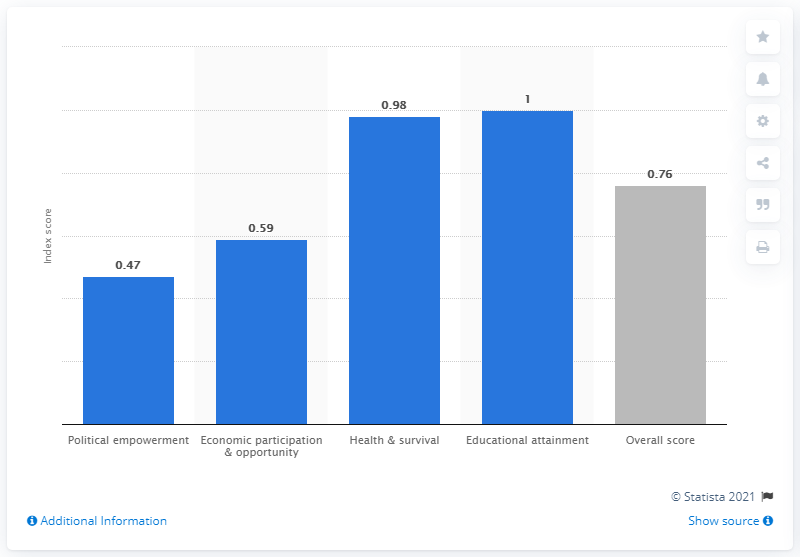Specify some key components in this picture. The gray bar represents the overall score for a property, which is a numerical value ranging from 0 to 100 that evaluates the property's performance in various categories. According to the gender gap index, political empowerment has the largest deviation from the overall score, followed by economic participation and opportunity, education, health and well-being, and political representation. 